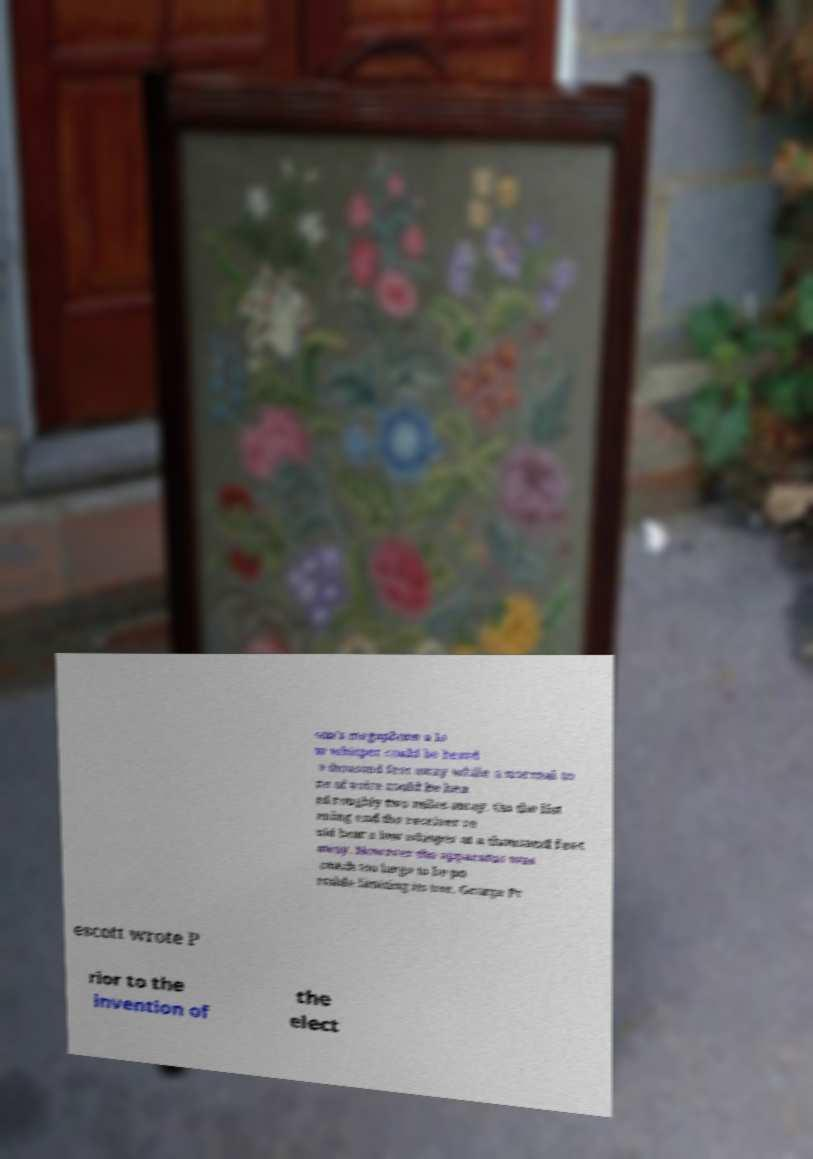For documentation purposes, I need the text within this image transcribed. Could you provide that? son's megaphone a lo w whisper could be heard a thousand feet away while a normal to ne of voice could be hea rd roughly two miles away. On the list ening end the receiver co uld hear a low whisper at a thousand feet away. However the apparatus was much too large to be po rtable limiting its use. George Pr escott wrote P rior to the invention of the elect 